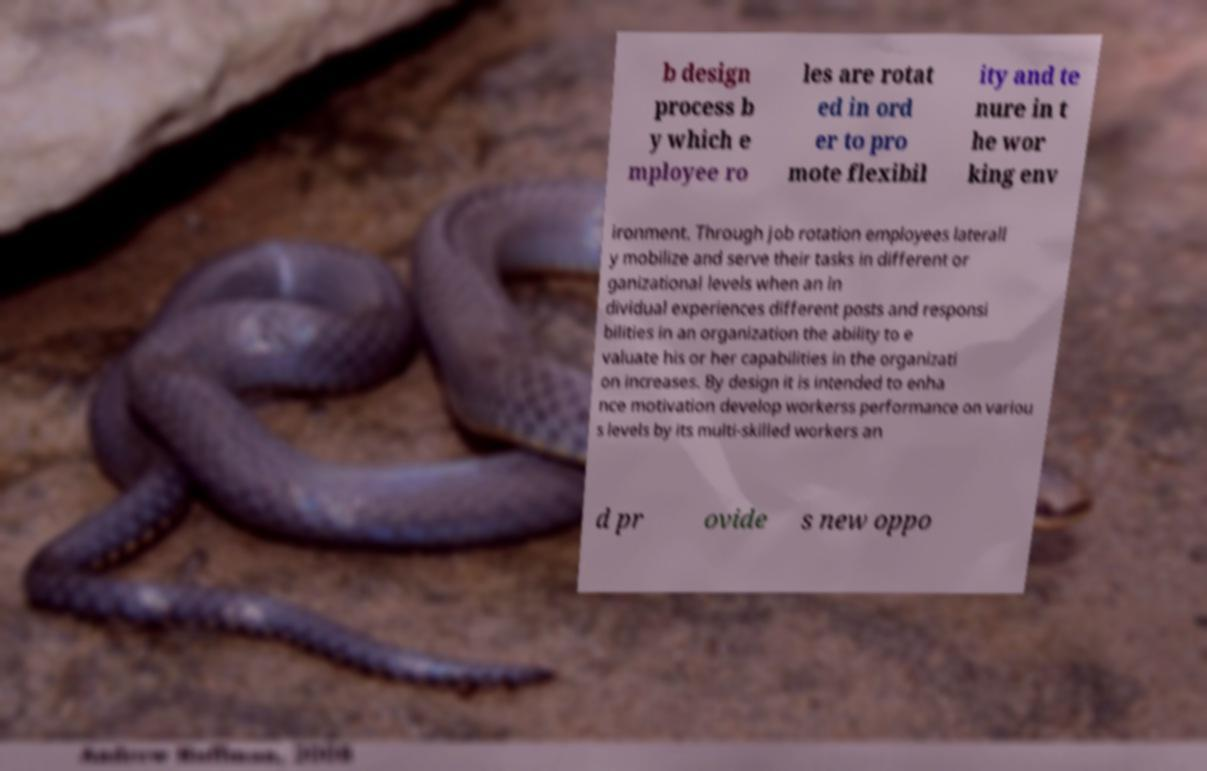I need the written content from this picture converted into text. Can you do that? b design process b y which e mployee ro les are rotat ed in ord er to pro mote flexibil ity and te nure in t he wor king env ironment. Through job rotation employees laterall y mobilize and serve their tasks in different or ganizational levels when an in dividual experiences different posts and responsi bilities in an organization the ability to e valuate his or her capabilities in the organizati on increases. By design it is intended to enha nce motivation develop workerss performance on variou s levels by its multi-skilled workers an d pr ovide s new oppo 